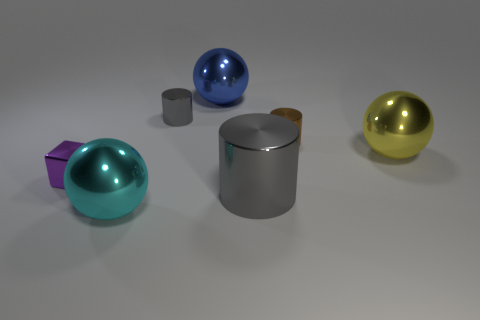Add 3 brown cylinders. How many objects exist? 10 Subtract all cubes. How many objects are left? 6 Subtract 0 gray blocks. How many objects are left? 7 Subtract all big red cubes. Subtract all small things. How many objects are left? 4 Add 7 large blue metallic objects. How many large blue metallic objects are left? 8 Add 6 blue metal objects. How many blue metal objects exist? 7 